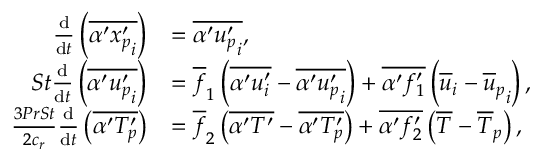<formula> <loc_0><loc_0><loc_500><loc_500>\begin{array} { r l } { \frac { d } { d t } \left ( \overline { { \alpha ^ { \prime } { x _ { p } ^ { \prime } } _ { i } } } \right ) } & { = \overline { { \alpha ^ { \prime } { u _ { p } ^ { \prime } } _ { i } } } , } \\ { S t \frac { d } { d t } \left ( \overline { { \alpha ^ { \prime } { u _ { p } ^ { \prime } } _ { i } } } \right ) } & { = \overline { f } _ { 1 } \left ( \overline { { \alpha ^ { \prime } u _ { i } ^ { \prime } } } - \overline { { \alpha ^ { \prime } { u _ { p } ^ { \prime } } _ { i } } } \right ) + \overline { { \alpha ^ { \prime } f _ { 1 } ^ { \prime } } } \left ( \overline { u } _ { i } - { \overline { u } _ { p } } _ { i } \right ) , } \\ { \frac { 3 P r S t } { 2 c _ { r } } \frac { d } { d t } \left ( \overline { { \alpha ^ { \prime } { T _ { p } ^ { \prime } } } } \right ) } & { = \overline { f } _ { 2 } \left ( \overline { { \alpha ^ { \prime } T ^ { \prime } } } - \overline { { \alpha ^ { \prime } { T _ { p } ^ { \prime } } } } \right ) + \overline { { \alpha ^ { \prime } f _ { 2 } ^ { \prime } } } \left ( \overline { T } - { \overline { T } _ { p } } \right ) , } \end{array}</formula> 